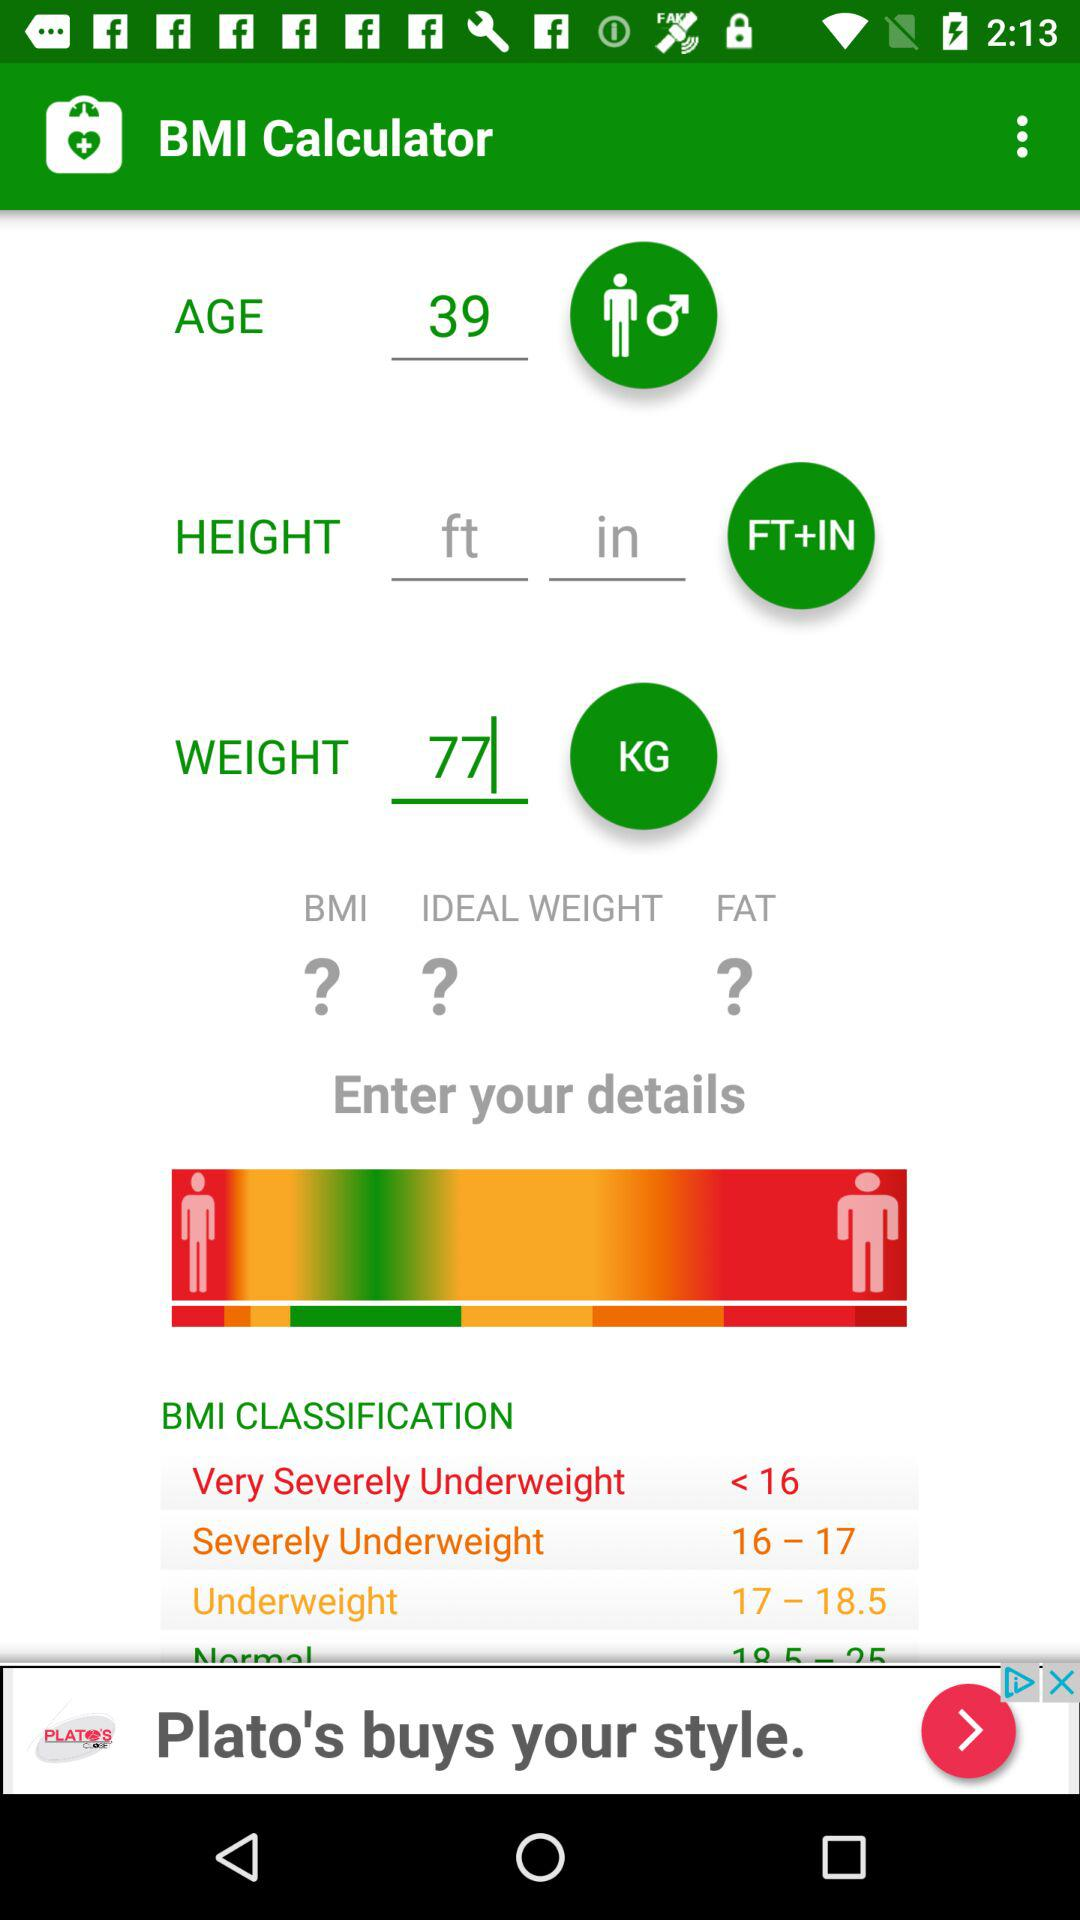What is the age? The age is 39. 